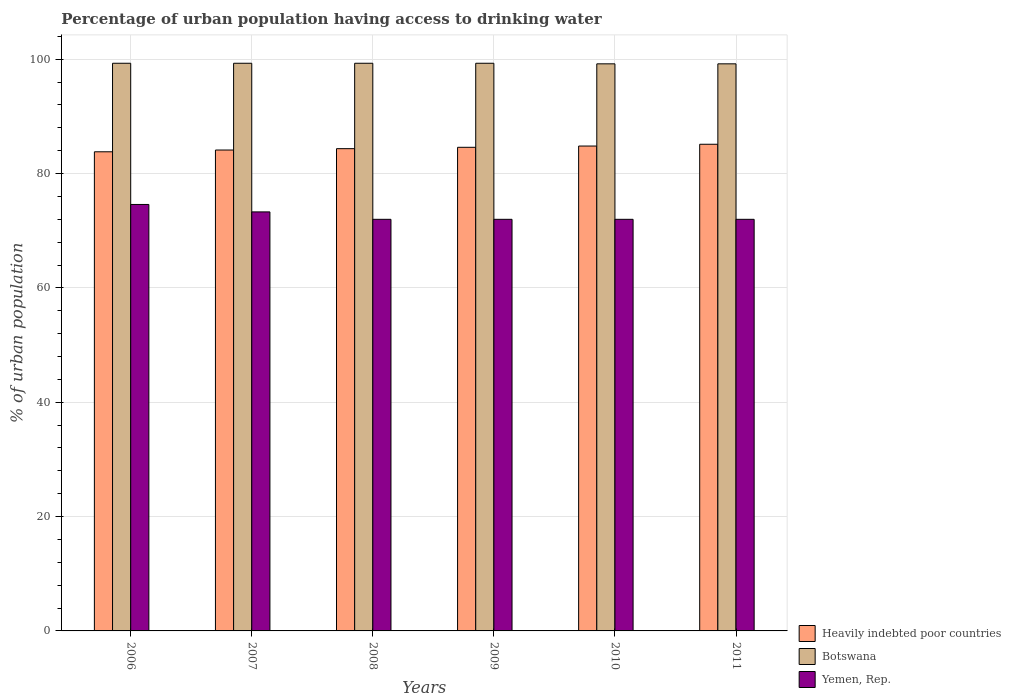How many groups of bars are there?
Provide a short and direct response. 6. Are the number of bars per tick equal to the number of legend labels?
Your response must be concise. Yes. In how many cases, is the number of bars for a given year not equal to the number of legend labels?
Ensure brevity in your answer.  0. What is the percentage of urban population having access to drinking water in Heavily indebted poor countries in 2006?
Ensure brevity in your answer.  83.81. Across all years, what is the maximum percentage of urban population having access to drinking water in Heavily indebted poor countries?
Make the answer very short. 85.13. In which year was the percentage of urban population having access to drinking water in Yemen, Rep. minimum?
Your answer should be compact. 2008. What is the total percentage of urban population having access to drinking water in Yemen, Rep. in the graph?
Provide a short and direct response. 435.9. What is the difference between the percentage of urban population having access to drinking water in Yemen, Rep. in 2007 and the percentage of urban population having access to drinking water in Botswana in 2011?
Your response must be concise. -25.9. What is the average percentage of urban population having access to drinking water in Botswana per year?
Give a very brief answer. 99.27. In the year 2009, what is the difference between the percentage of urban population having access to drinking water in Botswana and percentage of urban population having access to drinking water in Heavily indebted poor countries?
Your answer should be compact. 14.7. In how many years, is the percentage of urban population having access to drinking water in Yemen, Rep. greater than 44 %?
Offer a terse response. 6. What is the ratio of the percentage of urban population having access to drinking water in Botswana in 2006 to that in 2007?
Your answer should be compact. 1. Is the percentage of urban population having access to drinking water in Botswana in 2008 less than that in 2009?
Offer a very short reply. No. Is the difference between the percentage of urban population having access to drinking water in Botswana in 2006 and 2010 greater than the difference between the percentage of urban population having access to drinking water in Heavily indebted poor countries in 2006 and 2010?
Your answer should be very brief. Yes. What is the difference between the highest and the second highest percentage of urban population having access to drinking water in Botswana?
Offer a very short reply. 0. What is the difference between the highest and the lowest percentage of urban population having access to drinking water in Heavily indebted poor countries?
Give a very brief answer. 1.32. In how many years, is the percentage of urban population having access to drinking water in Yemen, Rep. greater than the average percentage of urban population having access to drinking water in Yemen, Rep. taken over all years?
Your answer should be compact. 2. What does the 3rd bar from the left in 2010 represents?
Your response must be concise. Yemen, Rep. What does the 2nd bar from the right in 2008 represents?
Offer a very short reply. Botswana. How many bars are there?
Provide a short and direct response. 18. How many years are there in the graph?
Ensure brevity in your answer.  6. What is the difference between two consecutive major ticks on the Y-axis?
Provide a short and direct response. 20. Does the graph contain grids?
Offer a terse response. Yes. Where does the legend appear in the graph?
Ensure brevity in your answer.  Bottom right. What is the title of the graph?
Provide a short and direct response. Percentage of urban population having access to drinking water. Does "Lesotho" appear as one of the legend labels in the graph?
Your answer should be very brief. No. What is the label or title of the Y-axis?
Your response must be concise. % of urban population. What is the % of urban population of Heavily indebted poor countries in 2006?
Your answer should be compact. 83.81. What is the % of urban population of Botswana in 2006?
Make the answer very short. 99.3. What is the % of urban population of Yemen, Rep. in 2006?
Your response must be concise. 74.6. What is the % of urban population of Heavily indebted poor countries in 2007?
Keep it short and to the point. 84.12. What is the % of urban population of Botswana in 2007?
Provide a succinct answer. 99.3. What is the % of urban population of Yemen, Rep. in 2007?
Provide a succinct answer. 73.3. What is the % of urban population of Heavily indebted poor countries in 2008?
Give a very brief answer. 84.36. What is the % of urban population in Botswana in 2008?
Provide a short and direct response. 99.3. What is the % of urban population of Heavily indebted poor countries in 2009?
Offer a terse response. 84.6. What is the % of urban population of Botswana in 2009?
Your answer should be compact. 99.3. What is the % of urban population of Heavily indebted poor countries in 2010?
Your answer should be very brief. 84.82. What is the % of urban population in Botswana in 2010?
Make the answer very short. 99.2. What is the % of urban population in Heavily indebted poor countries in 2011?
Provide a short and direct response. 85.13. What is the % of urban population of Botswana in 2011?
Your answer should be compact. 99.2. What is the % of urban population in Yemen, Rep. in 2011?
Ensure brevity in your answer.  72. Across all years, what is the maximum % of urban population in Heavily indebted poor countries?
Offer a terse response. 85.13. Across all years, what is the maximum % of urban population in Botswana?
Make the answer very short. 99.3. Across all years, what is the maximum % of urban population of Yemen, Rep.?
Keep it short and to the point. 74.6. Across all years, what is the minimum % of urban population of Heavily indebted poor countries?
Offer a very short reply. 83.81. Across all years, what is the minimum % of urban population of Botswana?
Your answer should be compact. 99.2. What is the total % of urban population of Heavily indebted poor countries in the graph?
Make the answer very short. 506.84. What is the total % of urban population in Botswana in the graph?
Your answer should be very brief. 595.6. What is the total % of urban population in Yemen, Rep. in the graph?
Your answer should be very brief. 435.9. What is the difference between the % of urban population in Heavily indebted poor countries in 2006 and that in 2007?
Provide a succinct answer. -0.31. What is the difference between the % of urban population in Yemen, Rep. in 2006 and that in 2007?
Give a very brief answer. 1.3. What is the difference between the % of urban population of Heavily indebted poor countries in 2006 and that in 2008?
Provide a short and direct response. -0.55. What is the difference between the % of urban population of Botswana in 2006 and that in 2008?
Provide a succinct answer. 0. What is the difference between the % of urban population of Heavily indebted poor countries in 2006 and that in 2009?
Offer a terse response. -0.79. What is the difference between the % of urban population in Botswana in 2006 and that in 2009?
Make the answer very short. 0. What is the difference between the % of urban population of Yemen, Rep. in 2006 and that in 2009?
Provide a succinct answer. 2.6. What is the difference between the % of urban population in Heavily indebted poor countries in 2006 and that in 2010?
Make the answer very short. -1.01. What is the difference between the % of urban population of Heavily indebted poor countries in 2006 and that in 2011?
Provide a succinct answer. -1.32. What is the difference between the % of urban population in Heavily indebted poor countries in 2007 and that in 2008?
Offer a very short reply. -0.24. What is the difference between the % of urban population of Heavily indebted poor countries in 2007 and that in 2009?
Your response must be concise. -0.48. What is the difference between the % of urban population in Yemen, Rep. in 2007 and that in 2009?
Offer a very short reply. 1.3. What is the difference between the % of urban population in Heavily indebted poor countries in 2007 and that in 2010?
Provide a succinct answer. -0.7. What is the difference between the % of urban population in Botswana in 2007 and that in 2010?
Provide a short and direct response. 0.1. What is the difference between the % of urban population of Heavily indebted poor countries in 2007 and that in 2011?
Give a very brief answer. -1.01. What is the difference between the % of urban population of Botswana in 2007 and that in 2011?
Provide a short and direct response. 0.1. What is the difference between the % of urban population in Heavily indebted poor countries in 2008 and that in 2009?
Your answer should be compact. -0.24. What is the difference between the % of urban population in Botswana in 2008 and that in 2009?
Provide a succinct answer. 0. What is the difference between the % of urban population of Yemen, Rep. in 2008 and that in 2009?
Provide a succinct answer. 0. What is the difference between the % of urban population in Heavily indebted poor countries in 2008 and that in 2010?
Provide a short and direct response. -0.46. What is the difference between the % of urban population of Botswana in 2008 and that in 2010?
Provide a succinct answer. 0.1. What is the difference between the % of urban population of Heavily indebted poor countries in 2008 and that in 2011?
Give a very brief answer. -0.77. What is the difference between the % of urban population in Yemen, Rep. in 2008 and that in 2011?
Your response must be concise. 0. What is the difference between the % of urban population of Heavily indebted poor countries in 2009 and that in 2010?
Your answer should be compact. -0.22. What is the difference between the % of urban population of Heavily indebted poor countries in 2009 and that in 2011?
Your answer should be compact. -0.53. What is the difference between the % of urban population in Botswana in 2009 and that in 2011?
Provide a succinct answer. 0.1. What is the difference between the % of urban population in Heavily indebted poor countries in 2010 and that in 2011?
Your answer should be compact. -0.31. What is the difference between the % of urban population in Heavily indebted poor countries in 2006 and the % of urban population in Botswana in 2007?
Make the answer very short. -15.49. What is the difference between the % of urban population in Heavily indebted poor countries in 2006 and the % of urban population in Yemen, Rep. in 2007?
Give a very brief answer. 10.51. What is the difference between the % of urban population of Heavily indebted poor countries in 2006 and the % of urban population of Botswana in 2008?
Give a very brief answer. -15.49. What is the difference between the % of urban population in Heavily indebted poor countries in 2006 and the % of urban population in Yemen, Rep. in 2008?
Provide a short and direct response. 11.81. What is the difference between the % of urban population of Botswana in 2006 and the % of urban population of Yemen, Rep. in 2008?
Your answer should be very brief. 27.3. What is the difference between the % of urban population in Heavily indebted poor countries in 2006 and the % of urban population in Botswana in 2009?
Offer a very short reply. -15.49. What is the difference between the % of urban population in Heavily indebted poor countries in 2006 and the % of urban population in Yemen, Rep. in 2009?
Offer a terse response. 11.81. What is the difference between the % of urban population in Botswana in 2006 and the % of urban population in Yemen, Rep. in 2009?
Offer a very short reply. 27.3. What is the difference between the % of urban population of Heavily indebted poor countries in 2006 and the % of urban population of Botswana in 2010?
Your response must be concise. -15.39. What is the difference between the % of urban population in Heavily indebted poor countries in 2006 and the % of urban population in Yemen, Rep. in 2010?
Your answer should be compact. 11.81. What is the difference between the % of urban population of Botswana in 2006 and the % of urban population of Yemen, Rep. in 2010?
Make the answer very short. 27.3. What is the difference between the % of urban population of Heavily indebted poor countries in 2006 and the % of urban population of Botswana in 2011?
Your answer should be compact. -15.39. What is the difference between the % of urban population in Heavily indebted poor countries in 2006 and the % of urban population in Yemen, Rep. in 2011?
Offer a terse response. 11.81. What is the difference between the % of urban population in Botswana in 2006 and the % of urban population in Yemen, Rep. in 2011?
Give a very brief answer. 27.3. What is the difference between the % of urban population of Heavily indebted poor countries in 2007 and the % of urban population of Botswana in 2008?
Provide a short and direct response. -15.18. What is the difference between the % of urban population of Heavily indebted poor countries in 2007 and the % of urban population of Yemen, Rep. in 2008?
Your answer should be compact. 12.12. What is the difference between the % of urban population in Botswana in 2007 and the % of urban population in Yemen, Rep. in 2008?
Give a very brief answer. 27.3. What is the difference between the % of urban population of Heavily indebted poor countries in 2007 and the % of urban population of Botswana in 2009?
Offer a very short reply. -15.18. What is the difference between the % of urban population of Heavily indebted poor countries in 2007 and the % of urban population of Yemen, Rep. in 2009?
Provide a short and direct response. 12.12. What is the difference between the % of urban population in Botswana in 2007 and the % of urban population in Yemen, Rep. in 2009?
Your response must be concise. 27.3. What is the difference between the % of urban population of Heavily indebted poor countries in 2007 and the % of urban population of Botswana in 2010?
Your answer should be very brief. -15.08. What is the difference between the % of urban population in Heavily indebted poor countries in 2007 and the % of urban population in Yemen, Rep. in 2010?
Keep it short and to the point. 12.12. What is the difference between the % of urban population of Botswana in 2007 and the % of urban population of Yemen, Rep. in 2010?
Keep it short and to the point. 27.3. What is the difference between the % of urban population in Heavily indebted poor countries in 2007 and the % of urban population in Botswana in 2011?
Your answer should be compact. -15.08. What is the difference between the % of urban population of Heavily indebted poor countries in 2007 and the % of urban population of Yemen, Rep. in 2011?
Ensure brevity in your answer.  12.12. What is the difference between the % of urban population of Botswana in 2007 and the % of urban population of Yemen, Rep. in 2011?
Your answer should be compact. 27.3. What is the difference between the % of urban population of Heavily indebted poor countries in 2008 and the % of urban population of Botswana in 2009?
Provide a short and direct response. -14.94. What is the difference between the % of urban population of Heavily indebted poor countries in 2008 and the % of urban population of Yemen, Rep. in 2009?
Keep it short and to the point. 12.36. What is the difference between the % of urban population in Botswana in 2008 and the % of urban population in Yemen, Rep. in 2009?
Make the answer very short. 27.3. What is the difference between the % of urban population of Heavily indebted poor countries in 2008 and the % of urban population of Botswana in 2010?
Your answer should be compact. -14.84. What is the difference between the % of urban population in Heavily indebted poor countries in 2008 and the % of urban population in Yemen, Rep. in 2010?
Give a very brief answer. 12.36. What is the difference between the % of urban population of Botswana in 2008 and the % of urban population of Yemen, Rep. in 2010?
Your answer should be very brief. 27.3. What is the difference between the % of urban population of Heavily indebted poor countries in 2008 and the % of urban population of Botswana in 2011?
Your answer should be very brief. -14.84. What is the difference between the % of urban population in Heavily indebted poor countries in 2008 and the % of urban population in Yemen, Rep. in 2011?
Your answer should be very brief. 12.36. What is the difference between the % of urban population in Botswana in 2008 and the % of urban population in Yemen, Rep. in 2011?
Provide a short and direct response. 27.3. What is the difference between the % of urban population in Heavily indebted poor countries in 2009 and the % of urban population in Botswana in 2010?
Offer a very short reply. -14.6. What is the difference between the % of urban population in Heavily indebted poor countries in 2009 and the % of urban population in Yemen, Rep. in 2010?
Keep it short and to the point. 12.6. What is the difference between the % of urban population of Botswana in 2009 and the % of urban population of Yemen, Rep. in 2010?
Keep it short and to the point. 27.3. What is the difference between the % of urban population of Heavily indebted poor countries in 2009 and the % of urban population of Botswana in 2011?
Your response must be concise. -14.6. What is the difference between the % of urban population in Heavily indebted poor countries in 2009 and the % of urban population in Yemen, Rep. in 2011?
Your answer should be very brief. 12.6. What is the difference between the % of urban population of Botswana in 2009 and the % of urban population of Yemen, Rep. in 2011?
Your response must be concise. 27.3. What is the difference between the % of urban population of Heavily indebted poor countries in 2010 and the % of urban population of Botswana in 2011?
Your answer should be compact. -14.38. What is the difference between the % of urban population of Heavily indebted poor countries in 2010 and the % of urban population of Yemen, Rep. in 2011?
Provide a short and direct response. 12.82. What is the difference between the % of urban population in Botswana in 2010 and the % of urban population in Yemen, Rep. in 2011?
Provide a succinct answer. 27.2. What is the average % of urban population of Heavily indebted poor countries per year?
Your response must be concise. 84.47. What is the average % of urban population in Botswana per year?
Your response must be concise. 99.27. What is the average % of urban population of Yemen, Rep. per year?
Ensure brevity in your answer.  72.65. In the year 2006, what is the difference between the % of urban population of Heavily indebted poor countries and % of urban population of Botswana?
Your answer should be very brief. -15.49. In the year 2006, what is the difference between the % of urban population in Heavily indebted poor countries and % of urban population in Yemen, Rep.?
Provide a short and direct response. 9.21. In the year 2006, what is the difference between the % of urban population of Botswana and % of urban population of Yemen, Rep.?
Give a very brief answer. 24.7. In the year 2007, what is the difference between the % of urban population in Heavily indebted poor countries and % of urban population in Botswana?
Offer a terse response. -15.18. In the year 2007, what is the difference between the % of urban population of Heavily indebted poor countries and % of urban population of Yemen, Rep.?
Provide a short and direct response. 10.82. In the year 2007, what is the difference between the % of urban population of Botswana and % of urban population of Yemen, Rep.?
Your response must be concise. 26. In the year 2008, what is the difference between the % of urban population of Heavily indebted poor countries and % of urban population of Botswana?
Ensure brevity in your answer.  -14.94. In the year 2008, what is the difference between the % of urban population of Heavily indebted poor countries and % of urban population of Yemen, Rep.?
Your answer should be very brief. 12.36. In the year 2008, what is the difference between the % of urban population in Botswana and % of urban population in Yemen, Rep.?
Your answer should be very brief. 27.3. In the year 2009, what is the difference between the % of urban population of Heavily indebted poor countries and % of urban population of Botswana?
Make the answer very short. -14.7. In the year 2009, what is the difference between the % of urban population in Heavily indebted poor countries and % of urban population in Yemen, Rep.?
Give a very brief answer. 12.6. In the year 2009, what is the difference between the % of urban population in Botswana and % of urban population in Yemen, Rep.?
Your answer should be compact. 27.3. In the year 2010, what is the difference between the % of urban population of Heavily indebted poor countries and % of urban population of Botswana?
Offer a terse response. -14.38. In the year 2010, what is the difference between the % of urban population in Heavily indebted poor countries and % of urban population in Yemen, Rep.?
Provide a succinct answer. 12.82. In the year 2010, what is the difference between the % of urban population of Botswana and % of urban population of Yemen, Rep.?
Offer a terse response. 27.2. In the year 2011, what is the difference between the % of urban population in Heavily indebted poor countries and % of urban population in Botswana?
Provide a succinct answer. -14.07. In the year 2011, what is the difference between the % of urban population of Heavily indebted poor countries and % of urban population of Yemen, Rep.?
Give a very brief answer. 13.13. In the year 2011, what is the difference between the % of urban population of Botswana and % of urban population of Yemen, Rep.?
Your response must be concise. 27.2. What is the ratio of the % of urban population in Yemen, Rep. in 2006 to that in 2007?
Offer a terse response. 1.02. What is the ratio of the % of urban population of Yemen, Rep. in 2006 to that in 2008?
Your response must be concise. 1.04. What is the ratio of the % of urban population in Heavily indebted poor countries in 2006 to that in 2009?
Provide a short and direct response. 0.99. What is the ratio of the % of urban population of Yemen, Rep. in 2006 to that in 2009?
Provide a short and direct response. 1.04. What is the ratio of the % of urban population of Botswana in 2006 to that in 2010?
Your answer should be compact. 1. What is the ratio of the % of urban population in Yemen, Rep. in 2006 to that in 2010?
Offer a very short reply. 1.04. What is the ratio of the % of urban population of Heavily indebted poor countries in 2006 to that in 2011?
Your answer should be compact. 0.98. What is the ratio of the % of urban population of Botswana in 2006 to that in 2011?
Your answer should be very brief. 1. What is the ratio of the % of urban population in Yemen, Rep. in 2006 to that in 2011?
Your answer should be compact. 1.04. What is the ratio of the % of urban population of Heavily indebted poor countries in 2007 to that in 2008?
Your answer should be compact. 1. What is the ratio of the % of urban population in Botswana in 2007 to that in 2008?
Give a very brief answer. 1. What is the ratio of the % of urban population in Yemen, Rep. in 2007 to that in 2008?
Keep it short and to the point. 1.02. What is the ratio of the % of urban population in Heavily indebted poor countries in 2007 to that in 2009?
Make the answer very short. 0.99. What is the ratio of the % of urban population of Yemen, Rep. in 2007 to that in 2009?
Give a very brief answer. 1.02. What is the ratio of the % of urban population of Heavily indebted poor countries in 2007 to that in 2010?
Offer a terse response. 0.99. What is the ratio of the % of urban population of Botswana in 2007 to that in 2010?
Give a very brief answer. 1. What is the ratio of the % of urban population in Yemen, Rep. in 2007 to that in 2010?
Offer a very short reply. 1.02. What is the ratio of the % of urban population in Yemen, Rep. in 2007 to that in 2011?
Keep it short and to the point. 1.02. What is the ratio of the % of urban population of Botswana in 2008 to that in 2009?
Keep it short and to the point. 1. What is the ratio of the % of urban population in Yemen, Rep. in 2008 to that in 2009?
Give a very brief answer. 1. What is the ratio of the % of urban population of Heavily indebted poor countries in 2008 to that in 2011?
Your answer should be compact. 0.99. What is the ratio of the % of urban population of Botswana in 2008 to that in 2011?
Your answer should be compact. 1. What is the ratio of the % of urban population of Yemen, Rep. in 2008 to that in 2011?
Your response must be concise. 1. What is the ratio of the % of urban population in Heavily indebted poor countries in 2009 to that in 2010?
Provide a succinct answer. 1. What is the ratio of the % of urban population of Botswana in 2009 to that in 2010?
Keep it short and to the point. 1. What is the ratio of the % of urban population of Yemen, Rep. in 2009 to that in 2010?
Provide a succinct answer. 1. What is the ratio of the % of urban population of Heavily indebted poor countries in 2009 to that in 2011?
Your answer should be very brief. 0.99. What is the ratio of the % of urban population of Botswana in 2009 to that in 2011?
Offer a very short reply. 1. What is the difference between the highest and the second highest % of urban population in Heavily indebted poor countries?
Your answer should be compact. 0.31. What is the difference between the highest and the second highest % of urban population in Botswana?
Provide a succinct answer. 0. What is the difference between the highest and the second highest % of urban population in Yemen, Rep.?
Give a very brief answer. 1.3. What is the difference between the highest and the lowest % of urban population of Heavily indebted poor countries?
Offer a very short reply. 1.32. What is the difference between the highest and the lowest % of urban population of Yemen, Rep.?
Make the answer very short. 2.6. 